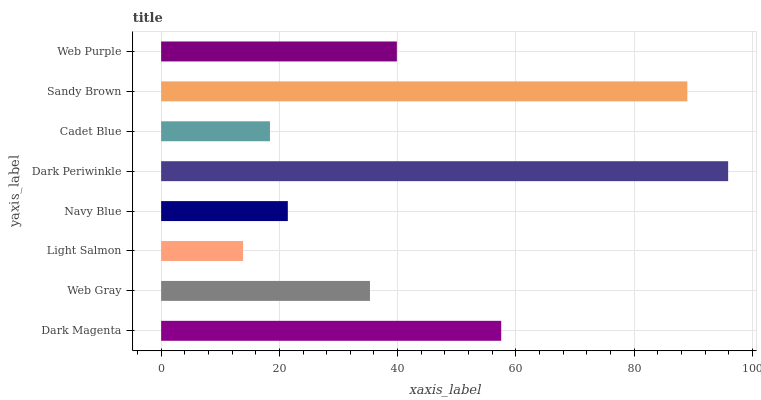Is Light Salmon the minimum?
Answer yes or no. Yes. Is Dark Periwinkle the maximum?
Answer yes or no. Yes. Is Web Gray the minimum?
Answer yes or no. No. Is Web Gray the maximum?
Answer yes or no. No. Is Dark Magenta greater than Web Gray?
Answer yes or no. Yes. Is Web Gray less than Dark Magenta?
Answer yes or no. Yes. Is Web Gray greater than Dark Magenta?
Answer yes or no. No. Is Dark Magenta less than Web Gray?
Answer yes or no. No. Is Web Purple the high median?
Answer yes or no. Yes. Is Web Gray the low median?
Answer yes or no. Yes. Is Light Salmon the high median?
Answer yes or no. No. Is Dark Magenta the low median?
Answer yes or no. No. 